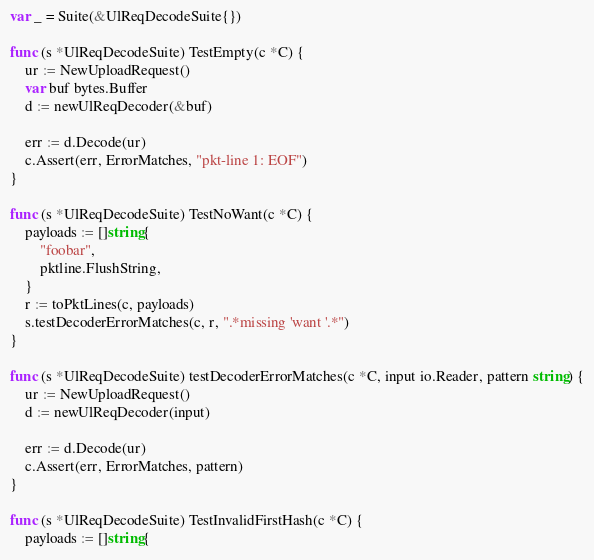<code> <loc_0><loc_0><loc_500><loc_500><_Go_>var _ = Suite(&UlReqDecodeSuite{})

func (s *UlReqDecodeSuite) TestEmpty(c *C) {
	ur := NewUploadRequest()
	var buf bytes.Buffer
	d := newUlReqDecoder(&buf)

	err := d.Decode(ur)
	c.Assert(err, ErrorMatches, "pkt-line 1: EOF")
}

func (s *UlReqDecodeSuite) TestNoWant(c *C) {
	payloads := []string{
		"foobar",
		pktline.FlushString,
	}
	r := toPktLines(c, payloads)
	s.testDecoderErrorMatches(c, r, ".*missing 'want '.*")
}

func (s *UlReqDecodeSuite) testDecoderErrorMatches(c *C, input io.Reader, pattern string) {
	ur := NewUploadRequest()
	d := newUlReqDecoder(input)

	err := d.Decode(ur)
	c.Assert(err, ErrorMatches, pattern)
}

func (s *UlReqDecodeSuite) TestInvalidFirstHash(c *C) {
	payloads := []string{</code> 